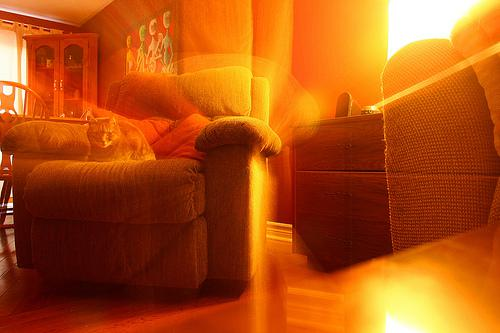Question: who is relaxing on the chair?
Choices:
A. The Grandfather.
B. The dog.
C. The Mom.
D. The cat.
Answer with the letter. Answer: D Question: when was this picture taken?
Choices:
A. In the evening.
B. In the morning.
C. At bath time.
D. At dinner time.
Answer with the letter. Answer: B Question: how is the light coming in?
Choices:
A. Through the sunroof.
B. Through the windows.
C. Through the open door.
D. Through the holes in the wall.
Answer with the letter. Answer: B 